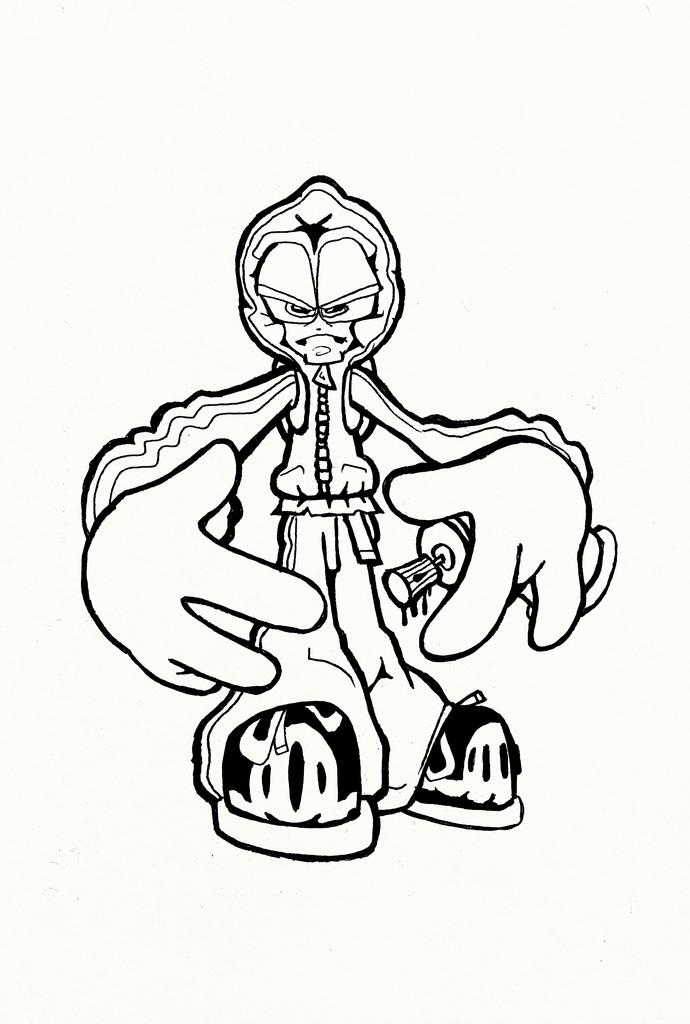What is depicted in the image? There is a drawing in the image. Can you describe the subject of the drawing? The drawing is of a cartoon. How many kisses can be seen in the image? There are no kisses present in the image; it features a drawing of a cartoon. What color is the bun on the cartoon character's head? There is no cartoon character with a bun in the image, as the drawing is not detailed enough to show such features. 